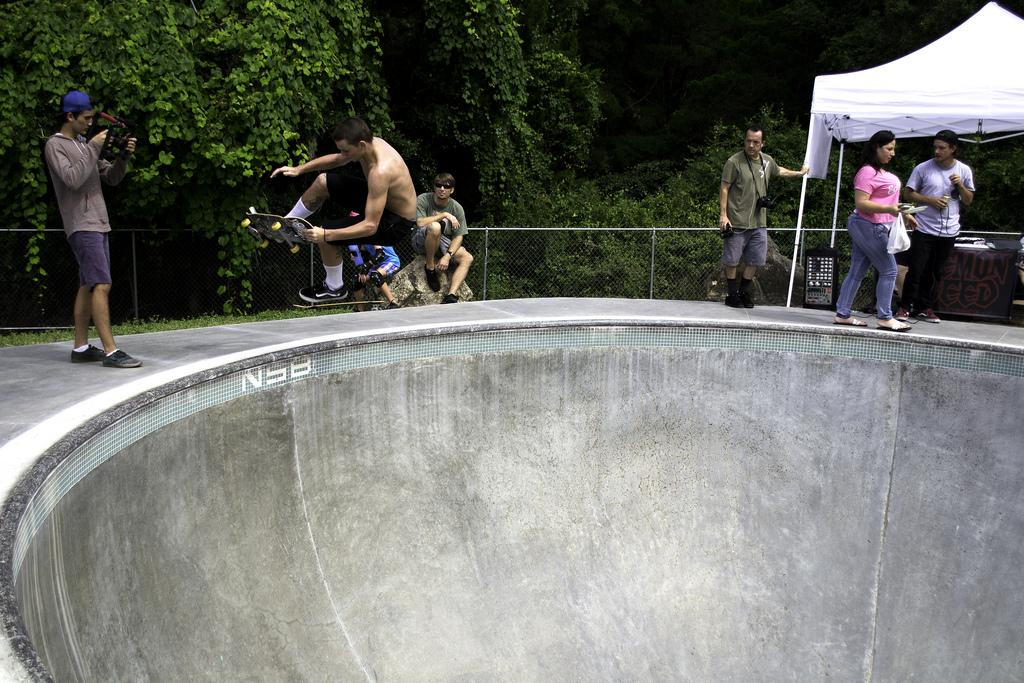Question: what letters are on the edge of the pool?
Choices:
A. Lep.
B. Nsb.
C. Ara.
D. Pel.
Answer with the letter. Answer: B Question: what surrounds the property?
Choices:
A. A fence.
B. Hedges.
C. Trees.
D. Railing.
Answer with the letter. Answer: A Question: who is on the skateboard?
Choices:
A. A man.
B. A woman.
C. A child.
D. A dog.
Answer with the letter. Answer: A Question: who has a blue hat?
Choices:
A. One guy.
B. The young boy.
C. The woman.
D. The player.
Answer with the letter. Answer: A Question: who is using the empty pool?
Choices:
A. Graffiti artists.
B. Skateboarders.
C. Pool repairmen.
D. Happy frogs.
Answer with the letter. Answer: B Question: what is in the background?
Choices:
A. Green foliage.
B. Mountains.
C. The horizon.
D. A forest.
Answer with the letter. Answer: A Question: why are these people here?
Choices:
A. To skateboard.
B. To ride bicycles.
C. To lay down.
D. To have a picnic.
Answer with the letter. Answer: A Question: what are the other people doing?
Choices:
A. Watching.
B. Sleeping.
C. Singing.
D. Dancing.
Answer with the letter. Answer: A Question: why is the skateboarder more at risk for injury?
Choices:
A. He is doing dangerous stunts.
B. He is a new skater.
C. He is not wearing protection.
D. His wheels are wobbly.
Answer with the letter. Answer: C Question: how many men are videotaping?
Choices:
A. 2.
B. 3.
C. 4.
D. 1.
Answer with the letter. Answer: D Question: what is the guy doing?
Choices:
A. Laughing.
B. Fighting.
C. Swimming.
D. Skateboarding.
Answer with the letter. Answer: D Question: how is the weather?
Choices:
A. Clear.
B. Cloudy.
C. Stormy.
D. Rainy.
Answer with the letter. Answer: A Question: where are the people at?
Choices:
A. Theater.
B. Beach.
C. A skatepark.
D. Concert.
Answer with the letter. Answer: C Question: what is behind the people?
Choices:
A. Trees.
B. Cats.
C. Dogs.
D. Friends.
Answer with the letter. Answer: A Question: what color are the trees?
Choices:
A. Green.
B. Purple.
C. Brown.
D. Yellow.
Answer with the letter. Answer: A Question: how would you describe the skateboarder's chest?
Choices:
A. Hairy chested.
B. Sparsly hairy chested.
C. Bare chested.
D. Scarred up chest.
Answer with the letter. Answer: C 